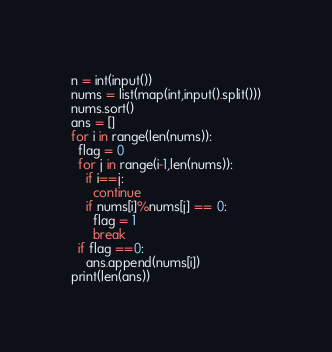<code> <loc_0><loc_0><loc_500><loc_500><_Python_>n = int(input())
nums = list(map(int,input().split()))
nums.sort()
ans = []
for i in range(len(nums)):
  flag = 0
  for j in range(i-1,len(nums)):
    if i==j:
      continue
    if nums[i]%nums[j] == 0:
      flag = 1
      break
  if flag ==0:
    ans.append(nums[i])
print(len(ans))
</code> 